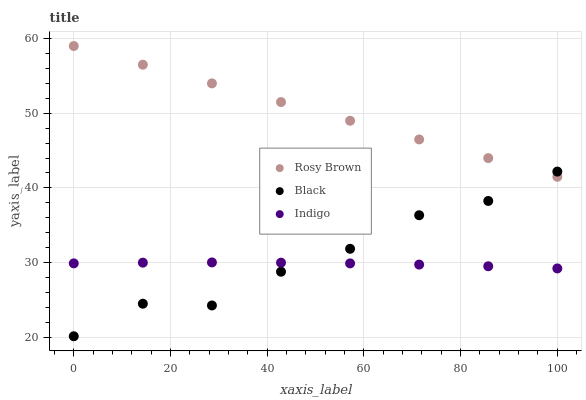Does Indigo have the minimum area under the curve?
Answer yes or no. Yes. Does Rosy Brown have the maximum area under the curve?
Answer yes or no. Yes. Does Black have the minimum area under the curve?
Answer yes or no. No. Does Black have the maximum area under the curve?
Answer yes or no. No. Is Rosy Brown the smoothest?
Answer yes or no. Yes. Is Black the roughest?
Answer yes or no. Yes. Is Black the smoothest?
Answer yes or no. No. Is Rosy Brown the roughest?
Answer yes or no. No. Does Black have the lowest value?
Answer yes or no. Yes. Does Rosy Brown have the lowest value?
Answer yes or no. No. Does Rosy Brown have the highest value?
Answer yes or no. Yes. Does Black have the highest value?
Answer yes or no. No. Is Indigo less than Rosy Brown?
Answer yes or no. Yes. Is Rosy Brown greater than Indigo?
Answer yes or no. Yes. Does Indigo intersect Black?
Answer yes or no. Yes. Is Indigo less than Black?
Answer yes or no. No. Is Indigo greater than Black?
Answer yes or no. No. Does Indigo intersect Rosy Brown?
Answer yes or no. No. 